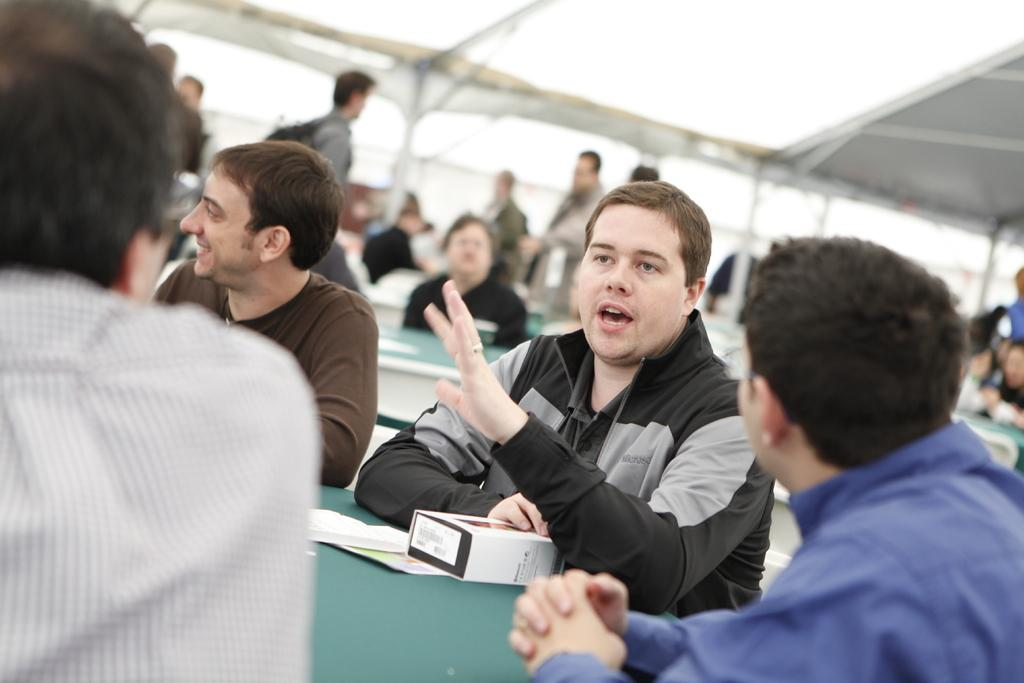What are the people in the image doing? There are people seated and standing in the image. What objects can be seen on the tables in the image? There are papers and a box on the tables in the image. How many tables are visible in the image? There are tables in the image. What type of tomatoes can be seen growing on the tables in the image? There are no tomatoes present in the image; the tables contain papers and a box. 